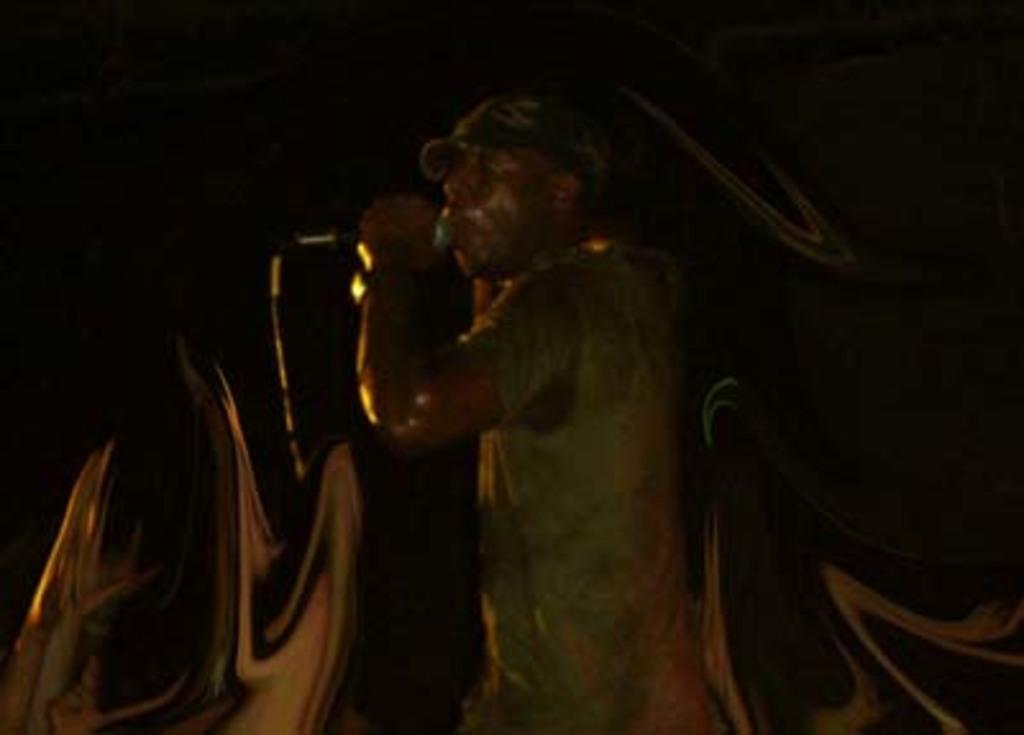Describe this image in one or two sentences. In this image, we can see a man standing and holding a microphone, there is a dark background. 